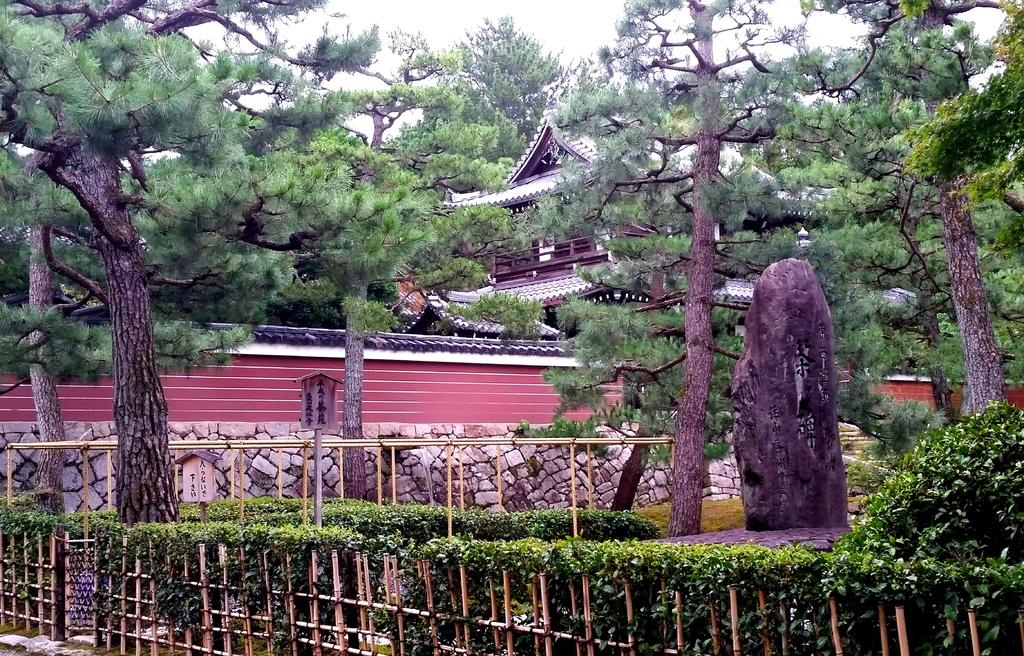What type of fencing can be seen in the image? There is a wooden fencing in the image. What kind of vegetation is present in the image? Small plants and trees are visible in the image. What is the closest object to the viewer in the image? There is a rock in the foreground of the image. What architectural feature can be seen in the background of the image? There is a stone wall in the background of the image. What type of structures are visible in the background of the image? Buildings are present in the background of the image. What is visible at the top of the image? The sky is visible at the top of the image. How many jellyfish are swimming in the rock in the foreground of the image? There are no jellyfish present in the image; it features a rock in the foreground. What type of straw is being used to decorate the stone wall in the background of the image? There is no straw present in the image, and the stone wall is not being used for decoration. 